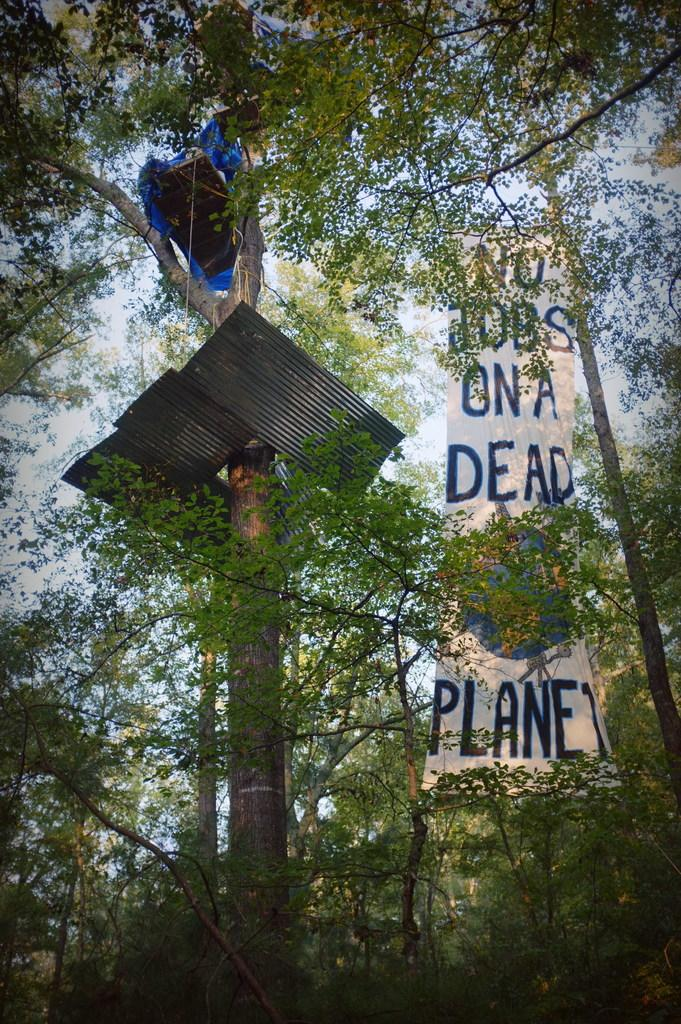What type of vegetation is at the bottom of the image? There are trees at the bottom of the image. What is located in the middle of the image? There is a cloth with text in the middle of the image. What material is present on the left side of the image? There are iron sheets on the left side of the image. What is visible at the top of the image? The sky is visible at the top of the image. Where is the nest of the bird in the image? There is no nest or bird present in the image. Can you tell me how many basketballs are visible in the image? There are no basketballs present in the image. 